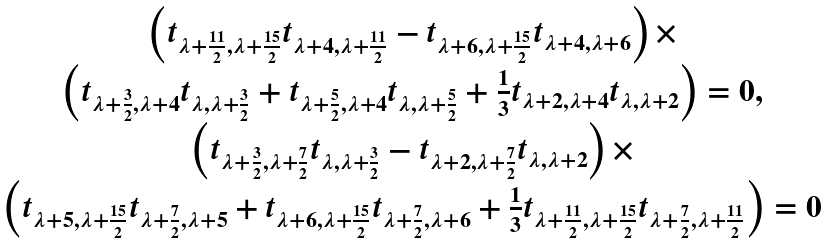Convert formula to latex. <formula><loc_0><loc_0><loc_500><loc_500>\begin{array} { c } \left ( t _ { \lambda + \frac { 1 1 } { 2 } , \lambda + \frac { 1 5 } { 2 } } t _ { \lambda + 4 , \lambda + \frac { 1 1 } { 2 } } - t _ { \lambda + 6 , \lambda + \frac { 1 5 } { 2 } } t _ { \lambda + 4 , \lambda + 6 } \right ) \times \\ \left ( t _ { \lambda + \frac { 3 } { 2 } , \lambda + 4 } t _ { \lambda , \lambda + \frac { 3 } { 2 } } + t _ { \lambda + \frac { 5 } { 2 } , \lambda + 4 } t _ { \lambda , \lambda + \frac { 5 } { 2 } } + \frac { 1 } { 3 } t _ { \lambda + 2 , \lambda + 4 } t _ { \lambda , \lambda + 2 } \right ) = 0 , \\ \left ( t _ { \lambda + \frac { 3 } { 2 } , \lambda + \frac { 7 } { 2 } } t _ { \lambda , \lambda + \frac { 3 } { 2 } } - t _ { \lambda + 2 , \lambda + \frac { 7 } { 2 } } t _ { \lambda , \lambda + 2 } \right ) \times \\ \left ( t _ { \lambda + 5 , \lambda + \frac { 1 5 } { 2 } } t _ { \lambda + \frac { 7 } { 2 } , \lambda + 5 } + t _ { \lambda + 6 , \lambda + \frac { 1 5 } { 2 } } t _ { \lambda + \frac { 7 } { 2 } , \lambda + 6 } + \frac { 1 } { 3 } t _ { \lambda + \frac { 1 1 } { 2 } , \lambda + \frac { 1 5 } { 2 } } t _ { \lambda + \frac { 7 } { 2 } , \lambda + \frac { 1 1 } { 2 } } \right ) = 0 \end{array}</formula> 